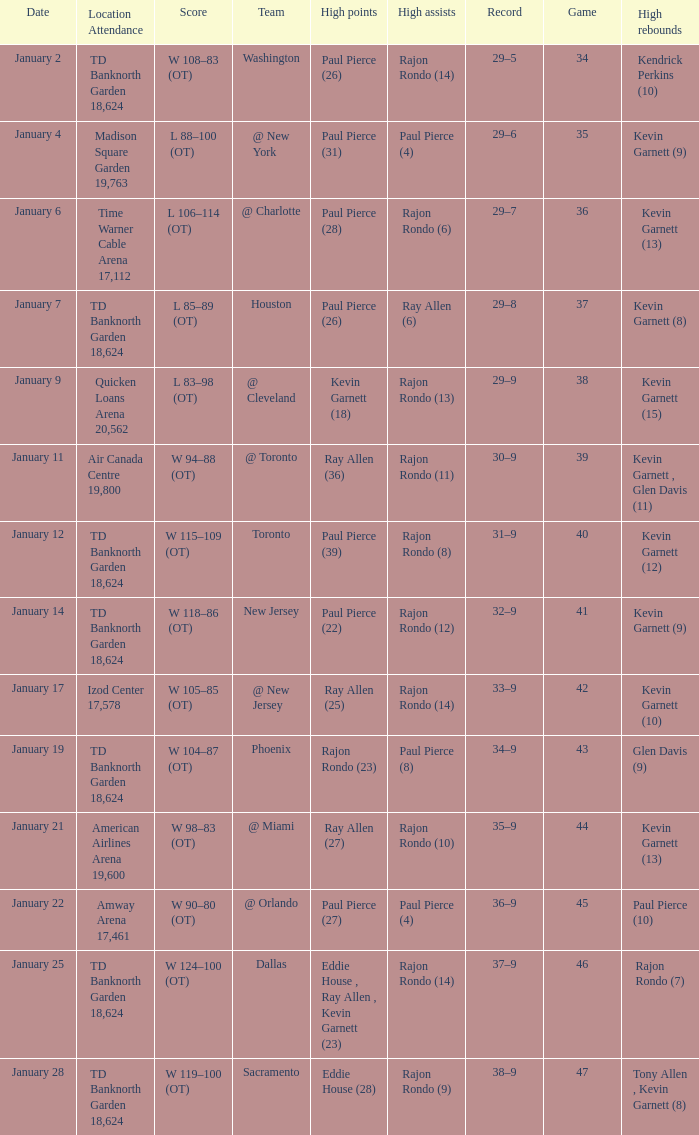Who had the high rebound total on january 6? Kevin Garnett (13). 